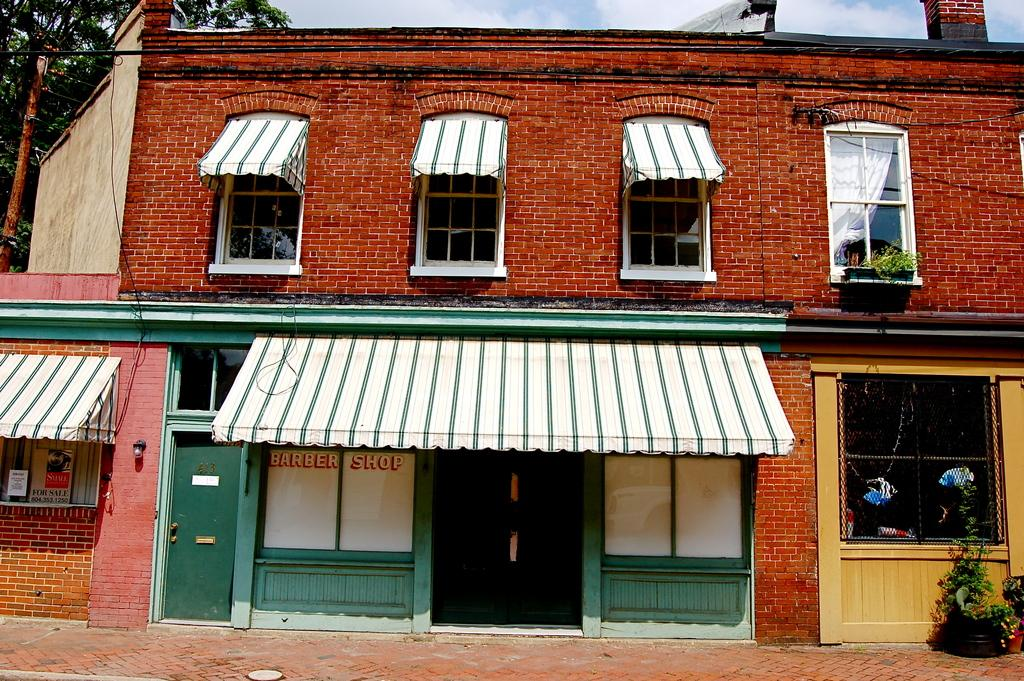What type of structure is in the image? There is a house in the image. What features can be seen on the house? The house has a roof, windows, and a door. Are there any other objects or elements in the image besides the house? Yes, there are plants and a pole in the image. What is the condition of the sky in the image? The sky is visible in the image and appears cloudy. How many pockets are visible on the house in the image? There are no pockets visible on the house in the image, as houses do not typically have pockets. What type of holiday is being celebrated in the image? There is no indication of a holiday being celebrated in the image. 